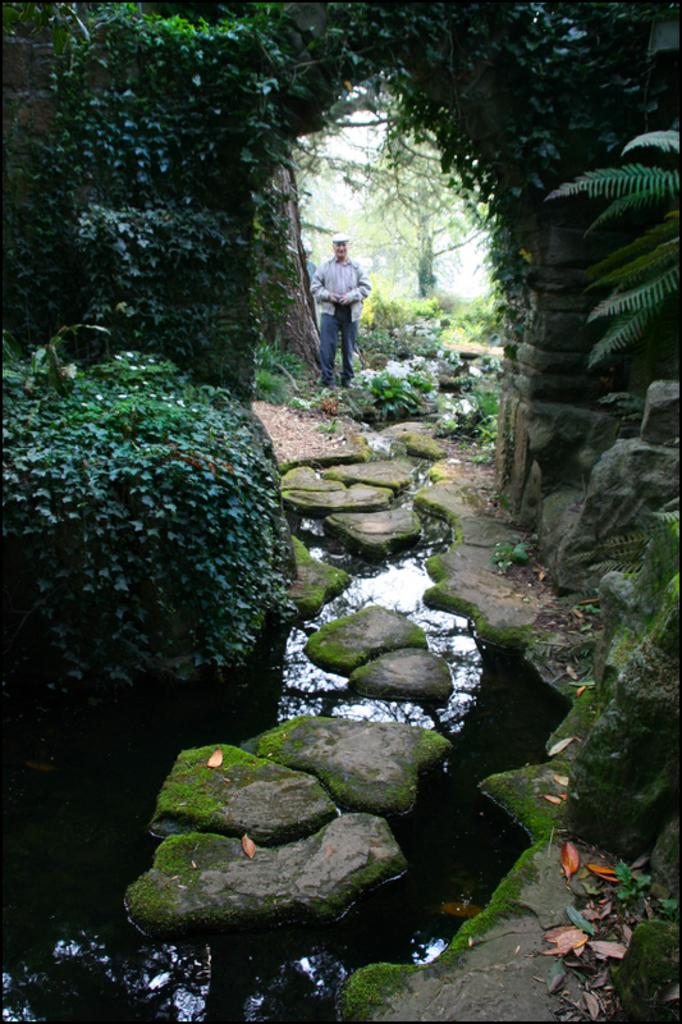What is the main element in the image? There is water in the image. What else can be seen in the image besides the water? There are stones in the image. Can you describe the background of the image? There are trees with a green color and the sky with a white color in the background of the image. Is there anyone visible in the image? Yes, there is a person standing in the background of the image. How many geese are walking on the stones in the image? There are no geese present in the image; it only features water, stones, a person, trees, and the sky. What type of shoe is the boy wearing in the image? There is no boy present in the image, so it is not possible to determine what type of shoe they might be wearing. 